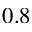<formula> <loc_0><loc_0><loc_500><loc_500>0 . 8</formula> 